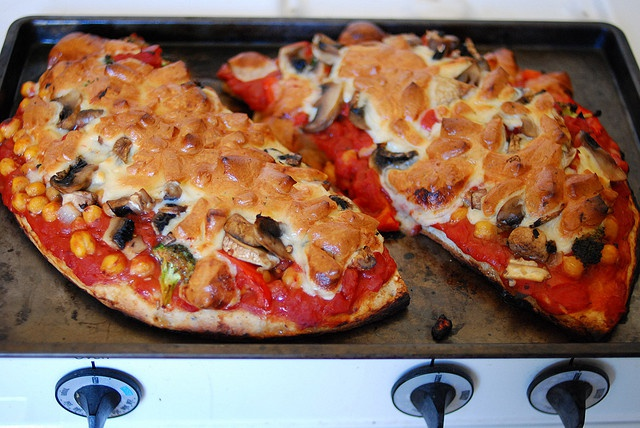Describe the objects in this image and their specific colors. I can see oven in black, lightblue, brown, and tan tones, pizza in lavender, tan, red, and brown tones, pizza in lavender, brown, tan, and maroon tones, and broccoli in lavender, olive, tan, and gray tones in this image. 